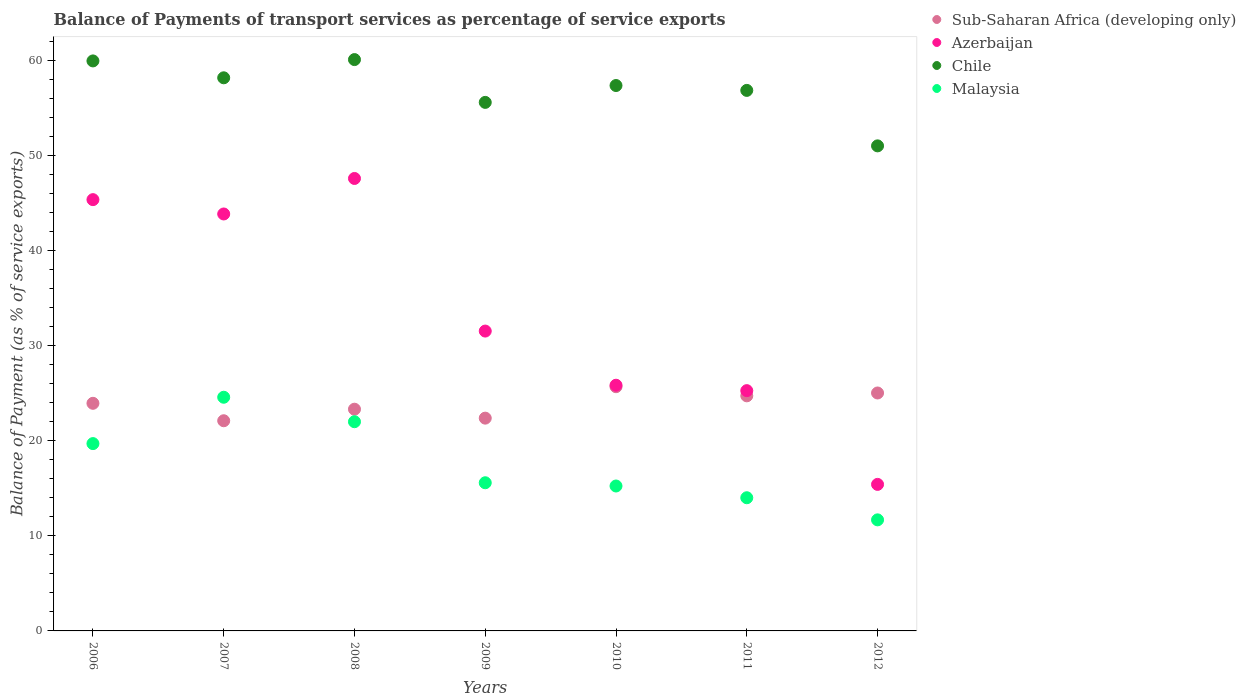How many different coloured dotlines are there?
Your response must be concise. 4. What is the balance of payments of transport services in Chile in 2010?
Give a very brief answer. 57.36. Across all years, what is the maximum balance of payments of transport services in Azerbaijan?
Your response must be concise. 47.58. Across all years, what is the minimum balance of payments of transport services in Chile?
Make the answer very short. 51.01. In which year was the balance of payments of transport services in Chile maximum?
Your answer should be compact. 2008. What is the total balance of payments of transport services in Malaysia in the graph?
Ensure brevity in your answer.  122.78. What is the difference between the balance of payments of transport services in Chile in 2010 and that in 2011?
Offer a terse response. 0.51. What is the difference between the balance of payments of transport services in Malaysia in 2006 and the balance of payments of transport services in Sub-Saharan Africa (developing only) in 2007?
Offer a very short reply. -2.4. What is the average balance of payments of transport services in Chile per year?
Provide a succinct answer. 57. In the year 2007, what is the difference between the balance of payments of transport services in Chile and balance of payments of transport services in Sub-Saharan Africa (developing only)?
Offer a terse response. 36.06. What is the ratio of the balance of payments of transport services in Malaysia in 2007 to that in 2010?
Offer a terse response. 1.61. Is the balance of payments of transport services in Sub-Saharan Africa (developing only) in 2006 less than that in 2008?
Give a very brief answer. No. What is the difference between the highest and the second highest balance of payments of transport services in Chile?
Give a very brief answer. 0.14. What is the difference between the highest and the lowest balance of payments of transport services in Sub-Saharan Africa (developing only)?
Your response must be concise. 3.58. In how many years, is the balance of payments of transport services in Sub-Saharan Africa (developing only) greater than the average balance of payments of transport services in Sub-Saharan Africa (developing only) taken over all years?
Make the answer very short. 4. Is it the case that in every year, the sum of the balance of payments of transport services in Chile and balance of payments of transport services in Malaysia  is greater than the sum of balance of payments of transport services in Sub-Saharan Africa (developing only) and balance of payments of transport services in Azerbaijan?
Keep it short and to the point. Yes. Does the balance of payments of transport services in Sub-Saharan Africa (developing only) monotonically increase over the years?
Provide a short and direct response. No. Is the balance of payments of transport services in Azerbaijan strictly less than the balance of payments of transport services in Chile over the years?
Provide a short and direct response. Yes. How many dotlines are there?
Provide a short and direct response. 4. Are the values on the major ticks of Y-axis written in scientific E-notation?
Your answer should be very brief. No. Does the graph contain any zero values?
Provide a succinct answer. No. Does the graph contain grids?
Provide a succinct answer. No. What is the title of the graph?
Your answer should be compact. Balance of Payments of transport services as percentage of service exports. Does "Switzerland" appear as one of the legend labels in the graph?
Keep it short and to the point. No. What is the label or title of the X-axis?
Your response must be concise. Years. What is the label or title of the Y-axis?
Provide a short and direct response. Balance of Payment (as % of service exports). What is the Balance of Payment (as % of service exports) of Sub-Saharan Africa (developing only) in 2006?
Your answer should be very brief. 23.94. What is the Balance of Payment (as % of service exports) of Azerbaijan in 2006?
Offer a terse response. 45.35. What is the Balance of Payment (as % of service exports) of Chile in 2006?
Make the answer very short. 59.94. What is the Balance of Payment (as % of service exports) in Malaysia in 2006?
Ensure brevity in your answer.  19.7. What is the Balance of Payment (as % of service exports) of Sub-Saharan Africa (developing only) in 2007?
Your response must be concise. 22.1. What is the Balance of Payment (as % of service exports) in Azerbaijan in 2007?
Offer a terse response. 43.85. What is the Balance of Payment (as % of service exports) in Chile in 2007?
Provide a succinct answer. 58.17. What is the Balance of Payment (as % of service exports) in Malaysia in 2007?
Make the answer very short. 24.57. What is the Balance of Payment (as % of service exports) of Sub-Saharan Africa (developing only) in 2008?
Offer a terse response. 23.32. What is the Balance of Payment (as % of service exports) in Azerbaijan in 2008?
Make the answer very short. 47.58. What is the Balance of Payment (as % of service exports) in Chile in 2008?
Offer a terse response. 60.08. What is the Balance of Payment (as % of service exports) in Malaysia in 2008?
Provide a succinct answer. 22. What is the Balance of Payment (as % of service exports) of Sub-Saharan Africa (developing only) in 2009?
Make the answer very short. 22.38. What is the Balance of Payment (as % of service exports) of Azerbaijan in 2009?
Your answer should be very brief. 31.53. What is the Balance of Payment (as % of service exports) in Chile in 2009?
Give a very brief answer. 55.58. What is the Balance of Payment (as % of service exports) of Malaysia in 2009?
Your answer should be very brief. 15.58. What is the Balance of Payment (as % of service exports) of Sub-Saharan Africa (developing only) in 2010?
Offer a terse response. 25.68. What is the Balance of Payment (as % of service exports) in Azerbaijan in 2010?
Offer a terse response. 25.84. What is the Balance of Payment (as % of service exports) of Chile in 2010?
Provide a short and direct response. 57.36. What is the Balance of Payment (as % of service exports) in Malaysia in 2010?
Ensure brevity in your answer.  15.24. What is the Balance of Payment (as % of service exports) in Sub-Saharan Africa (developing only) in 2011?
Offer a terse response. 24.72. What is the Balance of Payment (as % of service exports) in Azerbaijan in 2011?
Your answer should be very brief. 25.27. What is the Balance of Payment (as % of service exports) in Chile in 2011?
Make the answer very short. 56.84. What is the Balance of Payment (as % of service exports) in Malaysia in 2011?
Keep it short and to the point. 14.01. What is the Balance of Payment (as % of service exports) of Sub-Saharan Africa (developing only) in 2012?
Your answer should be very brief. 25.02. What is the Balance of Payment (as % of service exports) in Azerbaijan in 2012?
Your response must be concise. 15.41. What is the Balance of Payment (as % of service exports) in Chile in 2012?
Give a very brief answer. 51.01. What is the Balance of Payment (as % of service exports) in Malaysia in 2012?
Give a very brief answer. 11.68. Across all years, what is the maximum Balance of Payment (as % of service exports) of Sub-Saharan Africa (developing only)?
Keep it short and to the point. 25.68. Across all years, what is the maximum Balance of Payment (as % of service exports) in Azerbaijan?
Ensure brevity in your answer.  47.58. Across all years, what is the maximum Balance of Payment (as % of service exports) of Chile?
Your answer should be compact. 60.08. Across all years, what is the maximum Balance of Payment (as % of service exports) in Malaysia?
Offer a very short reply. 24.57. Across all years, what is the minimum Balance of Payment (as % of service exports) in Sub-Saharan Africa (developing only)?
Your answer should be compact. 22.1. Across all years, what is the minimum Balance of Payment (as % of service exports) in Azerbaijan?
Give a very brief answer. 15.41. Across all years, what is the minimum Balance of Payment (as % of service exports) of Chile?
Give a very brief answer. 51.01. Across all years, what is the minimum Balance of Payment (as % of service exports) of Malaysia?
Your answer should be very brief. 11.68. What is the total Balance of Payment (as % of service exports) in Sub-Saharan Africa (developing only) in the graph?
Give a very brief answer. 167.16. What is the total Balance of Payment (as % of service exports) of Azerbaijan in the graph?
Offer a terse response. 234.83. What is the total Balance of Payment (as % of service exports) in Chile in the graph?
Ensure brevity in your answer.  398.98. What is the total Balance of Payment (as % of service exports) in Malaysia in the graph?
Provide a short and direct response. 122.78. What is the difference between the Balance of Payment (as % of service exports) of Sub-Saharan Africa (developing only) in 2006 and that in 2007?
Provide a succinct answer. 1.83. What is the difference between the Balance of Payment (as % of service exports) of Azerbaijan in 2006 and that in 2007?
Make the answer very short. 1.51. What is the difference between the Balance of Payment (as % of service exports) in Chile in 2006 and that in 2007?
Provide a short and direct response. 1.78. What is the difference between the Balance of Payment (as % of service exports) of Malaysia in 2006 and that in 2007?
Provide a succinct answer. -4.87. What is the difference between the Balance of Payment (as % of service exports) of Sub-Saharan Africa (developing only) in 2006 and that in 2008?
Give a very brief answer. 0.62. What is the difference between the Balance of Payment (as % of service exports) in Azerbaijan in 2006 and that in 2008?
Provide a succinct answer. -2.23. What is the difference between the Balance of Payment (as % of service exports) of Chile in 2006 and that in 2008?
Offer a very short reply. -0.14. What is the difference between the Balance of Payment (as % of service exports) of Malaysia in 2006 and that in 2008?
Your answer should be compact. -2.3. What is the difference between the Balance of Payment (as % of service exports) of Sub-Saharan Africa (developing only) in 2006 and that in 2009?
Your answer should be very brief. 1.56. What is the difference between the Balance of Payment (as % of service exports) in Azerbaijan in 2006 and that in 2009?
Your response must be concise. 13.82. What is the difference between the Balance of Payment (as % of service exports) of Chile in 2006 and that in 2009?
Give a very brief answer. 4.36. What is the difference between the Balance of Payment (as % of service exports) of Malaysia in 2006 and that in 2009?
Offer a very short reply. 4.12. What is the difference between the Balance of Payment (as % of service exports) of Sub-Saharan Africa (developing only) in 2006 and that in 2010?
Your answer should be very brief. -1.75. What is the difference between the Balance of Payment (as % of service exports) of Azerbaijan in 2006 and that in 2010?
Give a very brief answer. 19.52. What is the difference between the Balance of Payment (as % of service exports) in Chile in 2006 and that in 2010?
Keep it short and to the point. 2.59. What is the difference between the Balance of Payment (as % of service exports) in Malaysia in 2006 and that in 2010?
Make the answer very short. 4.46. What is the difference between the Balance of Payment (as % of service exports) of Sub-Saharan Africa (developing only) in 2006 and that in 2011?
Your response must be concise. -0.79. What is the difference between the Balance of Payment (as % of service exports) in Azerbaijan in 2006 and that in 2011?
Provide a succinct answer. 20.09. What is the difference between the Balance of Payment (as % of service exports) of Chile in 2006 and that in 2011?
Offer a terse response. 3.1. What is the difference between the Balance of Payment (as % of service exports) in Malaysia in 2006 and that in 2011?
Offer a terse response. 5.69. What is the difference between the Balance of Payment (as % of service exports) in Sub-Saharan Africa (developing only) in 2006 and that in 2012?
Keep it short and to the point. -1.09. What is the difference between the Balance of Payment (as % of service exports) in Azerbaijan in 2006 and that in 2012?
Offer a very short reply. 29.94. What is the difference between the Balance of Payment (as % of service exports) of Chile in 2006 and that in 2012?
Ensure brevity in your answer.  8.93. What is the difference between the Balance of Payment (as % of service exports) of Malaysia in 2006 and that in 2012?
Your answer should be very brief. 8.02. What is the difference between the Balance of Payment (as % of service exports) in Sub-Saharan Africa (developing only) in 2007 and that in 2008?
Ensure brevity in your answer.  -1.21. What is the difference between the Balance of Payment (as % of service exports) of Azerbaijan in 2007 and that in 2008?
Your response must be concise. -3.73. What is the difference between the Balance of Payment (as % of service exports) of Chile in 2007 and that in 2008?
Provide a short and direct response. -1.92. What is the difference between the Balance of Payment (as % of service exports) in Malaysia in 2007 and that in 2008?
Keep it short and to the point. 2.57. What is the difference between the Balance of Payment (as % of service exports) in Sub-Saharan Africa (developing only) in 2007 and that in 2009?
Keep it short and to the point. -0.27. What is the difference between the Balance of Payment (as % of service exports) in Azerbaijan in 2007 and that in 2009?
Make the answer very short. 12.31. What is the difference between the Balance of Payment (as % of service exports) of Chile in 2007 and that in 2009?
Make the answer very short. 2.59. What is the difference between the Balance of Payment (as % of service exports) of Malaysia in 2007 and that in 2009?
Keep it short and to the point. 8.99. What is the difference between the Balance of Payment (as % of service exports) of Sub-Saharan Africa (developing only) in 2007 and that in 2010?
Make the answer very short. -3.58. What is the difference between the Balance of Payment (as % of service exports) of Azerbaijan in 2007 and that in 2010?
Provide a succinct answer. 18.01. What is the difference between the Balance of Payment (as % of service exports) in Chile in 2007 and that in 2010?
Your answer should be compact. 0.81. What is the difference between the Balance of Payment (as % of service exports) of Malaysia in 2007 and that in 2010?
Provide a short and direct response. 9.33. What is the difference between the Balance of Payment (as % of service exports) of Sub-Saharan Africa (developing only) in 2007 and that in 2011?
Provide a short and direct response. -2.62. What is the difference between the Balance of Payment (as % of service exports) of Azerbaijan in 2007 and that in 2011?
Offer a terse response. 18.58. What is the difference between the Balance of Payment (as % of service exports) in Chile in 2007 and that in 2011?
Provide a short and direct response. 1.32. What is the difference between the Balance of Payment (as % of service exports) of Malaysia in 2007 and that in 2011?
Your answer should be compact. 10.57. What is the difference between the Balance of Payment (as % of service exports) in Sub-Saharan Africa (developing only) in 2007 and that in 2012?
Your answer should be compact. -2.92. What is the difference between the Balance of Payment (as % of service exports) in Azerbaijan in 2007 and that in 2012?
Offer a terse response. 28.44. What is the difference between the Balance of Payment (as % of service exports) in Chile in 2007 and that in 2012?
Give a very brief answer. 7.16. What is the difference between the Balance of Payment (as % of service exports) of Malaysia in 2007 and that in 2012?
Give a very brief answer. 12.89. What is the difference between the Balance of Payment (as % of service exports) of Sub-Saharan Africa (developing only) in 2008 and that in 2009?
Offer a very short reply. 0.94. What is the difference between the Balance of Payment (as % of service exports) of Azerbaijan in 2008 and that in 2009?
Make the answer very short. 16.05. What is the difference between the Balance of Payment (as % of service exports) in Chile in 2008 and that in 2009?
Offer a terse response. 4.5. What is the difference between the Balance of Payment (as % of service exports) of Malaysia in 2008 and that in 2009?
Your response must be concise. 6.42. What is the difference between the Balance of Payment (as % of service exports) of Sub-Saharan Africa (developing only) in 2008 and that in 2010?
Your answer should be compact. -2.37. What is the difference between the Balance of Payment (as % of service exports) of Azerbaijan in 2008 and that in 2010?
Your answer should be very brief. 21.74. What is the difference between the Balance of Payment (as % of service exports) of Chile in 2008 and that in 2010?
Offer a very short reply. 2.73. What is the difference between the Balance of Payment (as % of service exports) of Malaysia in 2008 and that in 2010?
Ensure brevity in your answer.  6.76. What is the difference between the Balance of Payment (as % of service exports) in Sub-Saharan Africa (developing only) in 2008 and that in 2011?
Keep it short and to the point. -1.41. What is the difference between the Balance of Payment (as % of service exports) of Azerbaijan in 2008 and that in 2011?
Give a very brief answer. 22.31. What is the difference between the Balance of Payment (as % of service exports) in Chile in 2008 and that in 2011?
Your response must be concise. 3.24. What is the difference between the Balance of Payment (as % of service exports) in Malaysia in 2008 and that in 2011?
Offer a terse response. 8. What is the difference between the Balance of Payment (as % of service exports) in Sub-Saharan Africa (developing only) in 2008 and that in 2012?
Make the answer very short. -1.71. What is the difference between the Balance of Payment (as % of service exports) in Azerbaijan in 2008 and that in 2012?
Your response must be concise. 32.17. What is the difference between the Balance of Payment (as % of service exports) in Chile in 2008 and that in 2012?
Provide a succinct answer. 9.07. What is the difference between the Balance of Payment (as % of service exports) in Malaysia in 2008 and that in 2012?
Provide a succinct answer. 10.32. What is the difference between the Balance of Payment (as % of service exports) in Sub-Saharan Africa (developing only) in 2009 and that in 2010?
Provide a short and direct response. -3.3. What is the difference between the Balance of Payment (as % of service exports) in Azerbaijan in 2009 and that in 2010?
Your answer should be very brief. 5.69. What is the difference between the Balance of Payment (as % of service exports) in Chile in 2009 and that in 2010?
Keep it short and to the point. -1.77. What is the difference between the Balance of Payment (as % of service exports) of Malaysia in 2009 and that in 2010?
Provide a succinct answer. 0.34. What is the difference between the Balance of Payment (as % of service exports) of Sub-Saharan Africa (developing only) in 2009 and that in 2011?
Offer a very short reply. -2.35. What is the difference between the Balance of Payment (as % of service exports) of Azerbaijan in 2009 and that in 2011?
Give a very brief answer. 6.26. What is the difference between the Balance of Payment (as % of service exports) of Chile in 2009 and that in 2011?
Your answer should be compact. -1.26. What is the difference between the Balance of Payment (as % of service exports) of Malaysia in 2009 and that in 2011?
Your answer should be very brief. 1.58. What is the difference between the Balance of Payment (as % of service exports) in Sub-Saharan Africa (developing only) in 2009 and that in 2012?
Keep it short and to the point. -2.65. What is the difference between the Balance of Payment (as % of service exports) in Azerbaijan in 2009 and that in 2012?
Provide a succinct answer. 16.12. What is the difference between the Balance of Payment (as % of service exports) in Chile in 2009 and that in 2012?
Your answer should be very brief. 4.57. What is the difference between the Balance of Payment (as % of service exports) in Malaysia in 2009 and that in 2012?
Provide a succinct answer. 3.9. What is the difference between the Balance of Payment (as % of service exports) in Sub-Saharan Africa (developing only) in 2010 and that in 2011?
Make the answer very short. 0.96. What is the difference between the Balance of Payment (as % of service exports) of Azerbaijan in 2010 and that in 2011?
Offer a very short reply. 0.57. What is the difference between the Balance of Payment (as % of service exports) in Chile in 2010 and that in 2011?
Provide a succinct answer. 0.51. What is the difference between the Balance of Payment (as % of service exports) in Malaysia in 2010 and that in 2011?
Ensure brevity in your answer.  1.23. What is the difference between the Balance of Payment (as % of service exports) in Sub-Saharan Africa (developing only) in 2010 and that in 2012?
Your response must be concise. 0.66. What is the difference between the Balance of Payment (as % of service exports) of Azerbaijan in 2010 and that in 2012?
Make the answer very short. 10.43. What is the difference between the Balance of Payment (as % of service exports) of Chile in 2010 and that in 2012?
Keep it short and to the point. 6.35. What is the difference between the Balance of Payment (as % of service exports) in Malaysia in 2010 and that in 2012?
Your answer should be compact. 3.56. What is the difference between the Balance of Payment (as % of service exports) of Sub-Saharan Africa (developing only) in 2011 and that in 2012?
Your response must be concise. -0.3. What is the difference between the Balance of Payment (as % of service exports) in Azerbaijan in 2011 and that in 2012?
Ensure brevity in your answer.  9.86. What is the difference between the Balance of Payment (as % of service exports) of Chile in 2011 and that in 2012?
Make the answer very short. 5.83. What is the difference between the Balance of Payment (as % of service exports) in Malaysia in 2011 and that in 2012?
Provide a short and direct response. 2.33. What is the difference between the Balance of Payment (as % of service exports) in Sub-Saharan Africa (developing only) in 2006 and the Balance of Payment (as % of service exports) in Azerbaijan in 2007?
Your response must be concise. -19.91. What is the difference between the Balance of Payment (as % of service exports) of Sub-Saharan Africa (developing only) in 2006 and the Balance of Payment (as % of service exports) of Chile in 2007?
Your answer should be very brief. -34.23. What is the difference between the Balance of Payment (as % of service exports) in Sub-Saharan Africa (developing only) in 2006 and the Balance of Payment (as % of service exports) in Malaysia in 2007?
Offer a terse response. -0.64. What is the difference between the Balance of Payment (as % of service exports) of Azerbaijan in 2006 and the Balance of Payment (as % of service exports) of Chile in 2007?
Offer a very short reply. -12.81. What is the difference between the Balance of Payment (as % of service exports) in Azerbaijan in 2006 and the Balance of Payment (as % of service exports) in Malaysia in 2007?
Your response must be concise. 20.78. What is the difference between the Balance of Payment (as % of service exports) of Chile in 2006 and the Balance of Payment (as % of service exports) of Malaysia in 2007?
Give a very brief answer. 35.37. What is the difference between the Balance of Payment (as % of service exports) in Sub-Saharan Africa (developing only) in 2006 and the Balance of Payment (as % of service exports) in Azerbaijan in 2008?
Offer a terse response. -23.65. What is the difference between the Balance of Payment (as % of service exports) in Sub-Saharan Africa (developing only) in 2006 and the Balance of Payment (as % of service exports) in Chile in 2008?
Keep it short and to the point. -36.15. What is the difference between the Balance of Payment (as % of service exports) in Sub-Saharan Africa (developing only) in 2006 and the Balance of Payment (as % of service exports) in Malaysia in 2008?
Your answer should be compact. 1.94. What is the difference between the Balance of Payment (as % of service exports) of Azerbaijan in 2006 and the Balance of Payment (as % of service exports) of Chile in 2008?
Your answer should be very brief. -14.73. What is the difference between the Balance of Payment (as % of service exports) of Azerbaijan in 2006 and the Balance of Payment (as % of service exports) of Malaysia in 2008?
Give a very brief answer. 23.35. What is the difference between the Balance of Payment (as % of service exports) in Chile in 2006 and the Balance of Payment (as % of service exports) in Malaysia in 2008?
Your answer should be compact. 37.94. What is the difference between the Balance of Payment (as % of service exports) in Sub-Saharan Africa (developing only) in 2006 and the Balance of Payment (as % of service exports) in Azerbaijan in 2009?
Give a very brief answer. -7.6. What is the difference between the Balance of Payment (as % of service exports) of Sub-Saharan Africa (developing only) in 2006 and the Balance of Payment (as % of service exports) of Chile in 2009?
Your answer should be compact. -31.65. What is the difference between the Balance of Payment (as % of service exports) in Sub-Saharan Africa (developing only) in 2006 and the Balance of Payment (as % of service exports) in Malaysia in 2009?
Offer a very short reply. 8.36. What is the difference between the Balance of Payment (as % of service exports) of Azerbaijan in 2006 and the Balance of Payment (as % of service exports) of Chile in 2009?
Provide a succinct answer. -10.23. What is the difference between the Balance of Payment (as % of service exports) of Azerbaijan in 2006 and the Balance of Payment (as % of service exports) of Malaysia in 2009?
Make the answer very short. 29.77. What is the difference between the Balance of Payment (as % of service exports) of Chile in 2006 and the Balance of Payment (as % of service exports) of Malaysia in 2009?
Your response must be concise. 44.36. What is the difference between the Balance of Payment (as % of service exports) of Sub-Saharan Africa (developing only) in 2006 and the Balance of Payment (as % of service exports) of Azerbaijan in 2010?
Offer a very short reply. -1.9. What is the difference between the Balance of Payment (as % of service exports) of Sub-Saharan Africa (developing only) in 2006 and the Balance of Payment (as % of service exports) of Chile in 2010?
Your response must be concise. -33.42. What is the difference between the Balance of Payment (as % of service exports) of Sub-Saharan Africa (developing only) in 2006 and the Balance of Payment (as % of service exports) of Malaysia in 2010?
Ensure brevity in your answer.  8.7. What is the difference between the Balance of Payment (as % of service exports) in Azerbaijan in 2006 and the Balance of Payment (as % of service exports) in Chile in 2010?
Your answer should be compact. -12. What is the difference between the Balance of Payment (as % of service exports) of Azerbaijan in 2006 and the Balance of Payment (as % of service exports) of Malaysia in 2010?
Provide a short and direct response. 30.11. What is the difference between the Balance of Payment (as % of service exports) in Chile in 2006 and the Balance of Payment (as % of service exports) in Malaysia in 2010?
Offer a very short reply. 44.7. What is the difference between the Balance of Payment (as % of service exports) of Sub-Saharan Africa (developing only) in 2006 and the Balance of Payment (as % of service exports) of Azerbaijan in 2011?
Keep it short and to the point. -1.33. What is the difference between the Balance of Payment (as % of service exports) in Sub-Saharan Africa (developing only) in 2006 and the Balance of Payment (as % of service exports) in Chile in 2011?
Keep it short and to the point. -32.91. What is the difference between the Balance of Payment (as % of service exports) in Sub-Saharan Africa (developing only) in 2006 and the Balance of Payment (as % of service exports) in Malaysia in 2011?
Your response must be concise. 9.93. What is the difference between the Balance of Payment (as % of service exports) in Azerbaijan in 2006 and the Balance of Payment (as % of service exports) in Chile in 2011?
Offer a terse response. -11.49. What is the difference between the Balance of Payment (as % of service exports) of Azerbaijan in 2006 and the Balance of Payment (as % of service exports) of Malaysia in 2011?
Your answer should be compact. 31.35. What is the difference between the Balance of Payment (as % of service exports) of Chile in 2006 and the Balance of Payment (as % of service exports) of Malaysia in 2011?
Keep it short and to the point. 45.94. What is the difference between the Balance of Payment (as % of service exports) in Sub-Saharan Africa (developing only) in 2006 and the Balance of Payment (as % of service exports) in Azerbaijan in 2012?
Your answer should be compact. 8.53. What is the difference between the Balance of Payment (as % of service exports) of Sub-Saharan Africa (developing only) in 2006 and the Balance of Payment (as % of service exports) of Chile in 2012?
Provide a short and direct response. -27.07. What is the difference between the Balance of Payment (as % of service exports) of Sub-Saharan Africa (developing only) in 2006 and the Balance of Payment (as % of service exports) of Malaysia in 2012?
Offer a very short reply. 12.26. What is the difference between the Balance of Payment (as % of service exports) of Azerbaijan in 2006 and the Balance of Payment (as % of service exports) of Chile in 2012?
Ensure brevity in your answer.  -5.65. What is the difference between the Balance of Payment (as % of service exports) of Azerbaijan in 2006 and the Balance of Payment (as % of service exports) of Malaysia in 2012?
Your answer should be compact. 33.68. What is the difference between the Balance of Payment (as % of service exports) of Chile in 2006 and the Balance of Payment (as % of service exports) of Malaysia in 2012?
Provide a succinct answer. 48.26. What is the difference between the Balance of Payment (as % of service exports) in Sub-Saharan Africa (developing only) in 2007 and the Balance of Payment (as % of service exports) in Azerbaijan in 2008?
Provide a short and direct response. -25.48. What is the difference between the Balance of Payment (as % of service exports) of Sub-Saharan Africa (developing only) in 2007 and the Balance of Payment (as % of service exports) of Chile in 2008?
Provide a short and direct response. -37.98. What is the difference between the Balance of Payment (as % of service exports) of Sub-Saharan Africa (developing only) in 2007 and the Balance of Payment (as % of service exports) of Malaysia in 2008?
Give a very brief answer. 0.1. What is the difference between the Balance of Payment (as % of service exports) in Azerbaijan in 2007 and the Balance of Payment (as % of service exports) in Chile in 2008?
Offer a very short reply. -16.24. What is the difference between the Balance of Payment (as % of service exports) in Azerbaijan in 2007 and the Balance of Payment (as % of service exports) in Malaysia in 2008?
Offer a terse response. 21.85. What is the difference between the Balance of Payment (as % of service exports) of Chile in 2007 and the Balance of Payment (as % of service exports) of Malaysia in 2008?
Keep it short and to the point. 36.17. What is the difference between the Balance of Payment (as % of service exports) of Sub-Saharan Africa (developing only) in 2007 and the Balance of Payment (as % of service exports) of Azerbaijan in 2009?
Offer a very short reply. -9.43. What is the difference between the Balance of Payment (as % of service exports) in Sub-Saharan Africa (developing only) in 2007 and the Balance of Payment (as % of service exports) in Chile in 2009?
Provide a succinct answer. -33.48. What is the difference between the Balance of Payment (as % of service exports) in Sub-Saharan Africa (developing only) in 2007 and the Balance of Payment (as % of service exports) in Malaysia in 2009?
Your response must be concise. 6.52. What is the difference between the Balance of Payment (as % of service exports) in Azerbaijan in 2007 and the Balance of Payment (as % of service exports) in Chile in 2009?
Ensure brevity in your answer.  -11.73. What is the difference between the Balance of Payment (as % of service exports) in Azerbaijan in 2007 and the Balance of Payment (as % of service exports) in Malaysia in 2009?
Make the answer very short. 28.27. What is the difference between the Balance of Payment (as % of service exports) of Chile in 2007 and the Balance of Payment (as % of service exports) of Malaysia in 2009?
Provide a short and direct response. 42.59. What is the difference between the Balance of Payment (as % of service exports) of Sub-Saharan Africa (developing only) in 2007 and the Balance of Payment (as % of service exports) of Azerbaijan in 2010?
Offer a very short reply. -3.74. What is the difference between the Balance of Payment (as % of service exports) of Sub-Saharan Africa (developing only) in 2007 and the Balance of Payment (as % of service exports) of Chile in 2010?
Ensure brevity in your answer.  -35.25. What is the difference between the Balance of Payment (as % of service exports) of Sub-Saharan Africa (developing only) in 2007 and the Balance of Payment (as % of service exports) of Malaysia in 2010?
Make the answer very short. 6.86. What is the difference between the Balance of Payment (as % of service exports) of Azerbaijan in 2007 and the Balance of Payment (as % of service exports) of Chile in 2010?
Give a very brief answer. -13.51. What is the difference between the Balance of Payment (as % of service exports) in Azerbaijan in 2007 and the Balance of Payment (as % of service exports) in Malaysia in 2010?
Ensure brevity in your answer.  28.61. What is the difference between the Balance of Payment (as % of service exports) of Chile in 2007 and the Balance of Payment (as % of service exports) of Malaysia in 2010?
Make the answer very short. 42.93. What is the difference between the Balance of Payment (as % of service exports) of Sub-Saharan Africa (developing only) in 2007 and the Balance of Payment (as % of service exports) of Azerbaijan in 2011?
Make the answer very short. -3.17. What is the difference between the Balance of Payment (as % of service exports) in Sub-Saharan Africa (developing only) in 2007 and the Balance of Payment (as % of service exports) in Chile in 2011?
Your response must be concise. -34.74. What is the difference between the Balance of Payment (as % of service exports) in Sub-Saharan Africa (developing only) in 2007 and the Balance of Payment (as % of service exports) in Malaysia in 2011?
Your response must be concise. 8.1. What is the difference between the Balance of Payment (as % of service exports) of Azerbaijan in 2007 and the Balance of Payment (as % of service exports) of Chile in 2011?
Your answer should be very brief. -13. What is the difference between the Balance of Payment (as % of service exports) of Azerbaijan in 2007 and the Balance of Payment (as % of service exports) of Malaysia in 2011?
Ensure brevity in your answer.  29.84. What is the difference between the Balance of Payment (as % of service exports) in Chile in 2007 and the Balance of Payment (as % of service exports) in Malaysia in 2011?
Give a very brief answer. 44.16. What is the difference between the Balance of Payment (as % of service exports) in Sub-Saharan Africa (developing only) in 2007 and the Balance of Payment (as % of service exports) in Azerbaijan in 2012?
Your response must be concise. 6.69. What is the difference between the Balance of Payment (as % of service exports) in Sub-Saharan Africa (developing only) in 2007 and the Balance of Payment (as % of service exports) in Chile in 2012?
Provide a succinct answer. -28.91. What is the difference between the Balance of Payment (as % of service exports) in Sub-Saharan Africa (developing only) in 2007 and the Balance of Payment (as % of service exports) in Malaysia in 2012?
Provide a succinct answer. 10.42. What is the difference between the Balance of Payment (as % of service exports) of Azerbaijan in 2007 and the Balance of Payment (as % of service exports) of Chile in 2012?
Offer a very short reply. -7.16. What is the difference between the Balance of Payment (as % of service exports) of Azerbaijan in 2007 and the Balance of Payment (as % of service exports) of Malaysia in 2012?
Keep it short and to the point. 32.17. What is the difference between the Balance of Payment (as % of service exports) of Chile in 2007 and the Balance of Payment (as % of service exports) of Malaysia in 2012?
Your answer should be very brief. 46.49. What is the difference between the Balance of Payment (as % of service exports) in Sub-Saharan Africa (developing only) in 2008 and the Balance of Payment (as % of service exports) in Azerbaijan in 2009?
Your answer should be compact. -8.22. What is the difference between the Balance of Payment (as % of service exports) in Sub-Saharan Africa (developing only) in 2008 and the Balance of Payment (as % of service exports) in Chile in 2009?
Make the answer very short. -32.27. What is the difference between the Balance of Payment (as % of service exports) of Sub-Saharan Africa (developing only) in 2008 and the Balance of Payment (as % of service exports) of Malaysia in 2009?
Provide a short and direct response. 7.74. What is the difference between the Balance of Payment (as % of service exports) of Azerbaijan in 2008 and the Balance of Payment (as % of service exports) of Chile in 2009?
Provide a succinct answer. -8. What is the difference between the Balance of Payment (as % of service exports) of Azerbaijan in 2008 and the Balance of Payment (as % of service exports) of Malaysia in 2009?
Make the answer very short. 32. What is the difference between the Balance of Payment (as % of service exports) of Chile in 2008 and the Balance of Payment (as % of service exports) of Malaysia in 2009?
Make the answer very short. 44.5. What is the difference between the Balance of Payment (as % of service exports) in Sub-Saharan Africa (developing only) in 2008 and the Balance of Payment (as % of service exports) in Azerbaijan in 2010?
Give a very brief answer. -2.52. What is the difference between the Balance of Payment (as % of service exports) in Sub-Saharan Africa (developing only) in 2008 and the Balance of Payment (as % of service exports) in Chile in 2010?
Provide a short and direct response. -34.04. What is the difference between the Balance of Payment (as % of service exports) of Sub-Saharan Africa (developing only) in 2008 and the Balance of Payment (as % of service exports) of Malaysia in 2010?
Offer a very short reply. 8.08. What is the difference between the Balance of Payment (as % of service exports) of Azerbaijan in 2008 and the Balance of Payment (as % of service exports) of Chile in 2010?
Offer a terse response. -9.77. What is the difference between the Balance of Payment (as % of service exports) in Azerbaijan in 2008 and the Balance of Payment (as % of service exports) in Malaysia in 2010?
Your response must be concise. 32.34. What is the difference between the Balance of Payment (as % of service exports) of Chile in 2008 and the Balance of Payment (as % of service exports) of Malaysia in 2010?
Make the answer very short. 44.84. What is the difference between the Balance of Payment (as % of service exports) of Sub-Saharan Africa (developing only) in 2008 and the Balance of Payment (as % of service exports) of Azerbaijan in 2011?
Provide a short and direct response. -1.95. What is the difference between the Balance of Payment (as % of service exports) in Sub-Saharan Africa (developing only) in 2008 and the Balance of Payment (as % of service exports) in Chile in 2011?
Offer a terse response. -33.53. What is the difference between the Balance of Payment (as % of service exports) of Sub-Saharan Africa (developing only) in 2008 and the Balance of Payment (as % of service exports) of Malaysia in 2011?
Your response must be concise. 9.31. What is the difference between the Balance of Payment (as % of service exports) of Azerbaijan in 2008 and the Balance of Payment (as % of service exports) of Chile in 2011?
Make the answer very short. -9.26. What is the difference between the Balance of Payment (as % of service exports) of Azerbaijan in 2008 and the Balance of Payment (as % of service exports) of Malaysia in 2011?
Keep it short and to the point. 33.58. What is the difference between the Balance of Payment (as % of service exports) of Chile in 2008 and the Balance of Payment (as % of service exports) of Malaysia in 2011?
Your response must be concise. 46.08. What is the difference between the Balance of Payment (as % of service exports) of Sub-Saharan Africa (developing only) in 2008 and the Balance of Payment (as % of service exports) of Azerbaijan in 2012?
Provide a succinct answer. 7.91. What is the difference between the Balance of Payment (as % of service exports) in Sub-Saharan Africa (developing only) in 2008 and the Balance of Payment (as % of service exports) in Chile in 2012?
Keep it short and to the point. -27.69. What is the difference between the Balance of Payment (as % of service exports) in Sub-Saharan Africa (developing only) in 2008 and the Balance of Payment (as % of service exports) in Malaysia in 2012?
Provide a short and direct response. 11.64. What is the difference between the Balance of Payment (as % of service exports) in Azerbaijan in 2008 and the Balance of Payment (as % of service exports) in Chile in 2012?
Provide a short and direct response. -3.43. What is the difference between the Balance of Payment (as % of service exports) of Azerbaijan in 2008 and the Balance of Payment (as % of service exports) of Malaysia in 2012?
Offer a terse response. 35.9. What is the difference between the Balance of Payment (as % of service exports) in Chile in 2008 and the Balance of Payment (as % of service exports) in Malaysia in 2012?
Your answer should be very brief. 48.4. What is the difference between the Balance of Payment (as % of service exports) of Sub-Saharan Africa (developing only) in 2009 and the Balance of Payment (as % of service exports) of Azerbaijan in 2010?
Offer a terse response. -3.46. What is the difference between the Balance of Payment (as % of service exports) in Sub-Saharan Africa (developing only) in 2009 and the Balance of Payment (as % of service exports) in Chile in 2010?
Your answer should be very brief. -34.98. What is the difference between the Balance of Payment (as % of service exports) in Sub-Saharan Africa (developing only) in 2009 and the Balance of Payment (as % of service exports) in Malaysia in 2010?
Give a very brief answer. 7.14. What is the difference between the Balance of Payment (as % of service exports) of Azerbaijan in 2009 and the Balance of Payment (as % of service exports) of Chile in 2010?
Provide a succinct answer. -25.82. What is the difference between the Balance of Payment (as % of service exports) of Azerbaijan in 2009 and the Balance of Payment (as % of service exports) of Malaysia in 2010?
Offer a terse response. 16.29. What is the difference between the Balance of Payment (as % of service exports) in Chile in 2009 and the Balance of Payment (as % of service exports) in Malaysia in 2010?
Ensure brevity in your answer.  40.34. What is the difference between the Balance of Payment (as % of service exports) of Sub-Saharan Africa (developing only) in 2009 and the Balance of Payment (as % of service exports) of Azerbaijan in 2011?
Give a very brief answer. -2.89. What is the difference between the Balance of Payment (as % of service exports) of Sub-Saharan Africa (developing only) in 2009 and the Balance of Payment (as % of service exports) of Chile in 2011?
Ensure brevity in your answer.  -34.47. What is the difference between the Balance of Payment (as % of service exports) in Sub-Saharan Africa (developing only) in 2009 and the Balance of Payment (as % of service exports) in Malaysia in 2011?
Make the answer very short. 8.37. What is the difference between the Balance of Payment (as % of service exports) in Azerbaijan in 2009 and the Balance of Payment (as % of service exports) in Chile in 2011?
Offer a terse response. -25.31. What is the difference between the Balance of Payment (as % of service exports) in Azerbaijan in 2009 and the Balance of Payment (as % of service exports) in Malaysia in 2011?
Your response must be concise. 17.53. What is the difference between the Balance of Payment (as % of service exports) of Chile in 2009 and the Balance of Payment (as % of service exports) of Malaysia in 2011?
Offer a terse response. 41.58. What is the difference between the Balance of Payment (as % of service exports) of Sub-Saharan Africa (developing only) in 2009 and the Balance of Payment (as % of service exports) of Azerbaijan in 2012?
Provide a short and direct response. 6.97. What is the difference between the Balance of Payment (as % of service exports) in Sub-Saharan Africa (developing only) in 2009 and the Balance of Payment (as % of service exports) in Chile in 2012?
Provide a short and direct response. -28.63. What is the difference between the Balance of Payment (as % of service exports) of Sub-Saharan Africa (developing only) in 2009 and the Balance of Payment (as % of service exports) of Malaysia in 2012?
Make the answer very short. 10.7. What is the difference between the Balance of Payment (as % of service exports) in Azerbaijan in 2009 and the Balance of Payment (as % of service exports) in Chile in 2012?
Offer a very short reply. -19.48. What is the difference between the Balance of Payment (as % of service exports) in Azerbaijan in 2009 and the Balance of Payment (as % of service exports) in Malaysia in 2012?
Make the answer very short. 19.85. What is the difference between the Balance of Payment (as % of service exports) in Chile in 2009 and the Balance of Payment (as % of service exports) in Malaysia in 2012?
Give a very brief answer. 43.9. What is the difference between the Balance of Payment (as % of service exports) of Sub-Saharan Africa (developing only) in 2010 and the Balance of Payment (as % of service exports) of Azerbaijan in 2011?
Offer a very short reply. 0.41. What is the difference between the Balance of Payment (as % of service exports) in Sub-Saharan Africa (developing only) in 2010 and the Balance of Payment (as % of service exports) in Chile in 2011?
Offer a very short reply. -31.16. What is the difference between the Balance of Payment (as % of service exports) of Sub-Saharan Africa (developing only) in 2010 and the Balance of Payment (as % of service exports) of Malaysia in 2011?
Make the answer very short. 11.68. What is the difference between the Balance of Payment (as % of service exports) in Azerbaijan in 2010 and the Balance of Payment (as % of service exports) in Chile in 2011?
Keep it short and to the point. -31.01. What is the difference between the Balance of Payment (as % of service exports) in Azerbaijan in 2010 and the Balance of Payment (as % of service exports) in Malaysia in 2011?
Your answer should be compact. 11.83. What is the difference between the Balance of Payment (as % of service exports) in Chile in 2010 and the Balance of Payment (as % of service exports) in Malaysia in 2011?
Ensure brevity in your answer.  43.35. What is the difference between the Balance of Payment (as % of service exports) of Sub-Saharan Africa (developing only) in 2010 and the Balance of Payment (as % of service exports) of Azerbaijan in 2012?
Give a very brief answer. 10.27. What is the difference between the Balance of Payment (as % of service exports) of Sub-Saharan Africa (developing only) in 2010 and the Balance of Payment (as % of service exports) of Chile in 2012?
Keep it short and to the point. -25.33. What is the difference between the Balance of Payment (as % of service exports) of Sub-Saharan Africa (developing only) in 2010 and the Balance of Payment (as % of service exports) of Malaysia in 2012?
Keep it short and to the point. 14. What is the difference between the Balance of Payment (as % of service exports) of Azerbaijan in 2010 and the Balance of Payment (as % of service exports) of Chile in 2012?
Make the answer very short. -25.17. What is the difference between the Balance of Payment (as % of service exports) of Azerbaijan in 2010 and the Balance of Payment (as % of service exports) of Malaysia in 2012?
Make the answer very short. 14.16. What is the difference between the Balance of Payment (as % of service exports) in Chile in 2010 and the Balance of Payment (as % of service exports) in Malaysia in 2012?
Offer a terse response. 45.68. What is the difference between the Balance of Payment (as % of service exports) of Sub-Saharan Africa (developing only) in 2011 and the Balance of Payment (as % of service exports) of Azerbaijan in 2012?
Provide a succinct answer. 9.31. What is the difference between the Balance of Payment (as % of service exports) in Sub-Saharan Africa (developing only) in 2011 and the Balance of Payment (as % of service exports) in Chile in 2012?
Provide a short and direct response. -26.29. What is the difference between the Balance of Payment (as % of service exports) in Sub-Saharan Africa (developing only) in 2011 and the Balance of Payment (as % of service exports) in Malaysia in 2012?
Provide a short and direct response. 13.04. What is the difference between the Balance of Payment (as % of service exports) of Azerbaijan in 2011 and the Balance of Payment (as % of service exports) of Chile in 2012?
Provide a short and direct response. -25.74. What is the difference between the Balance of Payment (as % of service exports) of Azerbaijan in 2011 and the Balance of Payment (as % of service exports) of Malaysia in 2012?
Keep it short and to the point. 13.59. What is the difference between the Balance of Payment (as % of service exports) in Chile in 2011 and the Balance of Payment (as % of service exports) in Malaysia in 2012?
Your answer should be very brief. 45.16. What is the average Balance of Payment (as % of service exports) of Sub-Saharan Africa (developing only) per year?
Make the answer very short. 23.88. What is the average Balance of Payment (as % of service exports) in Azerbaijan per year?
Your response must be concise. 33.55. What is the average Balance of Payment (as % of service exports) of Chile per year?
Offer a very short reply. 57. What is the average Balance of Payment (as % of service exports) in Malaysia per year?
Keep it short and to the point. 17.54. In the year 2006, what is the difference between the Balance of Payment (as % of service exports) of Sub-Saharan Africa (developing only) and Balance of Payment (as % of service exports) of Azerbaijan?
Keep it short and to the point. -21.42. In the year 2006, what is the difference between the Balance of Payment (as % of service exports) in Sub-Saharan Africa (developing only) and Balance of Payment (as % of service exports) in Chile?
Your response must be concise. -36.01. In the year 2006, what is the difference between the Balance of Payment (as % of service exports) of Sub-Saharan Africa (developing only) and Balance of Payment (as % of service exports) of Malaysia?
Ensure brevity in your answer.  4.24. In the year 2006, what is the difference between the Balance of Payment (as % of service exports) of Azerbaijan and Balance of Payment (as % of service exports) of Chile?
Offer a very short reply. -14.59. In the year 2006, what is the difference between the Balance of Payment (as % of service exports) of Azerbaijan and Balance of Payment (as % of service exports) of Malaysia?
Your answer should be compact. 25.66. In the year 2006, what is the difference between the Balance of Payment (as % of service exports) in Chile and Balance of Payment (as % of service exports) in Malaysia?
Offer a terse response. 40.24. In the year 2007, what is the difference between the Balance of Payment (as % of service exports) of Sub-Saharan Africa (developing only) and Balance of Payment (as % of service exports) of Azerbaijan?
Your response must be concise. -21.74. In the year 2007, what is the difference between the Balance of Payment (as % of service exports) in Sub-Saharan Africa (developing only) and Balance of Payment (as % of service exports) in Chile?
Give a very brief answer. -36.06. In the year 2007, what is the difference between the Balance of Payment (as % of service exports) of Sub-Saharan Africa (developing only) and Balance of Payment (as % of service exports) of Malaysia?
Ensure brevity in your answer.  -2.47. In the year 2007, what is the difference between the Balance of Payment (as % of service exports) in Azerbaijan and Balance of Payment (as % of service exports) in Chile?
Offer a very short reply. -14.32. In the year 2007, what is the difference between the Balance of Payment (as % of service exports) of Azerbaijan and Balance of Payment (as % of service exports) of Malaysia?
Give a very brief answer. 19.27. In the year 2007, what is the difference between the Balance of Payment (as % of service exports) of Chile and Balance of Payment (as % of service exports) of Malaysia?
Make the answer very short. 33.59. In the year 2008, what is the difference between the Balance of Payment (as % of service exports) in Sub-Saharan Africa (developing only) and Balance of Payment (as % of service exports) in Azerbaijan?
Ensure brevity in your answer.  -24.27. In the year 2008, what is the difference between the Balance of Payment (as % of service exports) of Sub-Saharan Africa (developing only) and Balance of Payment (as % of service exports) of Chile?
Your answer should be very brief. -36.77. In the year 2008, what is the difference between the Balance of Payment (as % of service exports) in Sub-Saharan Africa (developing only) and Balance of Payment (as % of service exports) in Malaysia?
Your response must be concise. 1.32. In the year 2008, what is the difference between the Balance of Payment (as % of service exports) in Azerbaijan and Balance of Payment (as % of service exports) in Chile?
Offer a terse response. -12.5. In the year 2008, what is the difference between the Balance of Payment (as % of service exports) in Azerbaijan and Balance of Payment (as % of service exports) in Malaysia?
Ensure brevity in your answer.  25.58. In the year 2008, what is the difference between the Balance of Payment (as % of service exports) of Chile and Balance of Payment (as % of service exports) of Malaysia?
Offer a very short reply. 38.08. In the year 2009, what is the difference between the Balance of Payment (as % of service exports) of Sub-Saharan Africa (developing only) and Balance of Payment (as % of service exports) of Azerbaijan?
Provide a short and direct response. -9.16. In the year 2009, what is the difference between the Balance of Payment (as % of service exports) in Sub-Saharan Africa (developing only) and Balance of Payment (as % of service exports) in Chile?
Give a very brief answer. -33.21. In the year 2009, what is the difference between the Balance of Payment (as % of service exports) in Sub-Saharan Africa (developing only) and Balance of Payment (as % of service exports) in Malaysia?
Give a very brief answer. 6.8. In the year 2009, what is the difference between the Balance of Payment (as % of service exports) in Azerbaijan and Balance of Payment (as % of service exports) in Chile?
Make the answer very short. -24.05. In the year 2009, what is the difference between the Balance of Payment (as % of service exports) of Azerbaijan and Balance of Payment (as % of service exports) of Malaysia?
Keep it short and to the point. 15.95. In the year 2009, what is the difference between the Balance of Payment (as % of service exports) of Chile and Balance of Payment (as % of service exports) of Malaysia?
Your answer should be very brief. 40. In the year 2010, what is the difference between the Balance of Payment (as % of service exports) of Sub-Saharan Africa (developing only) and Balance of Payment (as % of service exports) of Azerbaijan?
Your response must be concise. -0.16. In the year 2010, what is the difference between the Balance of Payment (as % of service exports) in Sub-Saharan Africa (developing only) and Balance of Payment (as % of service exports) in Chile?
Your response must be concise. -31.67. In the year 2010, what is the difference between the Balance of Payment (as % of service exports) in Sub-Saharan Africa (developing only) and Balance of Payment (as % of service exports) in Malaysia?
Offer a very short reply. 10.44. In the year 2010, what is the difference between the Balance of Payment (as % of service exports) of Azerbaijan and Balance of Payment (as % of service exports) of Chile?
Keep it short and to the point. -31.52. In the year 2010, what is the difference between the Balance of Payment (as % of service exports) in Azerbaijan and Balance of Payment (as % of service exports) in Malaysia?
Make the answer very short. 10.6. In the year 2010, what is the difference between the Balance of Payment (as % of service exports) in Chile and Balance of Payment (as % of service exports) in Malaysia?
Give a very brief answer. 42.12. In the year 2011, what is the difference between the Balance of Payment (as % of service exports) of Sub-Saharan Africa (developing only) and Balance of Payment (as % of service exports) of Azerbaijan?
Your answer should be very brief. -0.55. In the year 2011, what is the difference between the Balance of Payment (as % of service exports) in Sub-Saharan Africa (developing only) and Balance of Payment (as % of service exports) in Chile?
Offer a very short reply. -32.12. In the year 2011, what is the difference between the Balance of Payment (as % of service exports) of Sub-Saharan Africa (developing only) and Balance of Payment (as % of service exports) of Malaysia?
Provide a short and direct response. 10.72. In the year 2011, what is the difference between the Balance of Payment (as % of service exports) of Azerbaijan and Balance of Payment (as % of service exports) of Chile?
Offer a very short reply. -31.58. In the year 2011, what is the difference between the Balance of Payment (as % of service exports) in Azerbaijan and Balance of Payment (as % of service exports) in Malaysia?
Your answer should be compact. 11.26. In the year 2011, what is the difference between the Balance of Payment (as % of service exports) in Chile and Balance of Payment (as % of service exports) in Malaysia?
Your answer should be very brief. 42.84. In the year 2012, what is the difference between the Balance of Payment (as % of service exports) of Sub-Saharan Africa (developing only) and Balance of Payment (as % of service exports) of Azerbaijan?
Keep it short and to the point. 9.61. In the year 2012, what is the difference between the Balance of Payment (as % of service exports) in Sub-Saharan Africa (developing only) and Balance of Payment (as % of service exports) in Chile?
Ensure brevity in your answer.  -25.99. In the year 2012, what is the difference between the Balance of Payment (as % of service exports) in Sub-Saharan Africa (developing only) and Balance of Payment (as % of service exports) in Malaysia?
Your answer should be compact. 13.34. In the year 2012, what is the difference between the Balance of Payment (as % of service exports) of Azerbaijan and Balance of Payment (as % of service exports) of Chile?
Keep it short and to the point. -35.6. In the year 2012, what is the difference between the Balance of Payment (as % of service exports) in Azerbaijan and Balance of Payment (as % of service exports) in Malaysia?
Keep it short and to the point. 3.73. In the year 2012, what is the difference between the Balance of Payment (as % of service exports) of Chile and Balance of Payment (as % of service exports) of Malaysia?
Offer a terse response. 39.33. What is the ratio of the Balance of Payment (as % of service exports) of Sub-Saharan Africa (developing only) in 2006 to that in 2007?
Keep it short and to the point. 1.08. What is the ratio of the Balance of Payment (as % of service exports) in Azerbaijan in 2006 to that in 2007?
Provide a succinct answer. 1.03. What is the ratio of the Balance of Payment (as % of service exports) of Chile in 2006 to that in 2007?
Ensure brevity in your answer.  1.03. What is the ratio of the Balance of Payment (as % of service exports) in Malaysia in 2006 to that in 2007?
Make the answer very short. 0.8. What is the ratio of the Balance of Payment (as % of service exports) in Sub-Saharan Africa (developing only) in 2006 to that in 2008?
Offer a terse response. 1.03. What is the ratio of the Balance of Payment (as % of service exports) of Azerbaijan in 2006 to that in 2008?
Ensure brevity in your answer.  0.95. What is the ratio of the Balance of Payment (as % of service exports) in Malaysia in 2006 to that in 2008?
Your answer should be very brief. 0.9. What is the ratio of the Balance of Payment (as % of service exports) in Sub-Saharan Africa (developing only) in 2006 to that in 2009?
Keep it short and to the point. 1.07. What is the ratio of the Balance of Payment (as % of service exports) of Azerbaijan in 2006 to that in 2009?
Ensure brevity in your answer.  1.44. What is the ratio of the Balance of Payment (as % of service exports) in Chile in 2006 to that in 2009?
Provide a short and direct response. 1.08. What is the ratio of the Balance of Payment (as % of service exports) in Malaysia in 2006 to that in 2009?
Provide a succinct answer. 1.26. What is the ratio of the Balance of Payment (as % of service exports) of Sub-Saharan Africa (developing only) in 2006 to that in 2010?
Your answer should be very brief. 0.93. What is the ratio of the Balance of Payment (as % of service exports) in Azerbaijan in 2006 to that in 2010?
Provide a succinct answer. 1.76. What is the ratio of the Balance of Payment (as % of service exports) in Chile in 2006 to that in 2010?
Offer a very short reply. 1.05. What is the ratio of the Balance of Payment (as % of service exports) of Malaysia in 2006 to that in 2010?
Ensure brevity in your answer.  1.29. What is the ratio of the Balance of Payment (as % of service exports) in Sub-Saharan Africa (developing only) in 2006 to that in 2011?
Offer a very short reply. 0.97. What is the ratio of the Balance of Payment (as % of service exports) in Azerbaijan in 2006 to that in 2011?
Provide a succinct answer. 1.79. What is the ratio of the Balance of Payment (as % of service exports) in Chile in 2006 to that in 2011?
Give a very brief answer. 1.05. What is the ratio of the Balance of Payment (as % of service exports) of Malaysia in 2006 to that in 2011?
Ensure brevity in your answer.  1.41. What is the ratio of the Balance of Payment (as % of service exports) in Sub-Saharan Africa (developing only) in 2006 to that in 2012?
Provide a short and direct response. 0.96. What is the ratio of the Balance of Payment (as % of service exports) in Azerbaijan in 2006 to that in 2012?
Make the answer very short. 2.94. What is the ratio of the Balance of Payment (as % of service exports) of Chile in 2006 to that in 2012?
Your response must be concise. 1.18. What is the ratio of the Balance of Payment (as % of service exports) in Malaysia in 2006 to that in 2012?
Provide a succinct answer. 1.69. What is the ratio of the Balance of Payment (as % of service exports) in Sub-Saharan Africa (developing only) in 2007 to that in 2008?
Provide a short and direct response. 0.95. What is the ratio of the Balance of Payment (as % of service exports) in Azerbaijan in 2007 to that in 2008?
Give a very brief answer. 0.92. What is the ratio of the Balance of Payment (as % of service exports) of Chile in 2007 to that in 2008?
Your answer should be compact. 0.97. What is the ratio of the Balance of Payment (as % of service exports) in Malaysia in 2007 to that in 2008?
Give a very brief answer. 1.12. What is the ratio of the Balance of Payment (as % of service exports) in Sub-Saharan Africa (developing only) in 2007 to that in 2009?
Ensure brevity in your answer.  0.99. What is the ratio of the Balance of Payment (as % of service exports) of Azerbaijan in 2007 to that in 2009?
Offer a very short reply. 1.39. What is the ratio of the Balance of Payment (as % of service exports) in Chile in 2007 to that in 2009?
Provide a succinct answer. 1.05. What is the ratio of the Balance of Payment (as % of service exports) in Malaysia in 2007 to that in 2009?
Ensure brevity in your answer.  1.58. What is the ratio of the Balance of Payment (as % of service exports) of Sub-Saharan Africa (developing only) in 2007 to that in 2010?
Your answer should be compact. 0.86. What is the ratio of the Balance of Payment (as % of service exports) of Azerbaijan in 2007 to that in 2010?
Keep it short and to the point. 1.7. What is the ratio of the Balance of Payment (as % of service exports) in Chile in 2007 to that in 2010?
Make the answer very short. 1.01. What is the ratio of the Balance of Payment (as % of service exports) of Malaysia in 2007 to that in 2010?
Offer a very short reply. 1.61. What is the ratio of the Balance of Payment (as % of service exports) of Sub-Saharan Africa (developing only) in 2007 to that in 2011?
Keep it short and to the point. 0.89. What is the ratio of the Balance of Payment (as % of service exports) in Azerbaijan in 2007 to that in 2011?
Offer a terse response. 1.74. What is the ratio of the Balance of Payment (as % of service exports) of Chile in 2007 to that in 2011?
Provide a short and direct response. 1.02. What is the ratio of the Balance of Payment (as % of service exports) in Malaysia in 2007 to that in 2011?
Offer a very short reply. 1.75. What is the ratio of the Balance of Payment (as % of service exports) in Sub-Saharan Africa (developing only) in 2007 to that in 2012?
Offer a terse response. 0.88. What is the ratio of the Balance of Payment (as % of service exports) of Azerbaijan in 2007 to that in 2012?
Ensure brevity in your answer.  2.85. What is the ratio of the Balance of Payment (as % of service exports) of Chile in 2007 to that in 2012?
Your response must be concise. 1.14. What is the ratio of the Balance of Payment (as % of service exports) in Malaysia in 2007 to that in 2012?
Provide a short and direct response. 2.1. What is the ratio of the Balance of Payment (as % of service exports) of Sub-Saharan Africa (developing only) in 2008 to that in 2009?
Offer a very short reply. 1.04. What is the ratio of the Balance of Payment (as % of service exports) in Azerbaijan in 2008 to that in 2009?
Your answer should be very brief. 1.51. What is the ratio of the Balance of Payment (as % of service exports) in Chile in 2008 to that in 2009?
Keep it short and to the point. 1.08. What is the ratio of the Balance of Payment (as % of service exports) in Malaysia in 2008 to that in 2009?
Provide a short and direct response. 1.41. What is the ratio of the Balance of Payment (as % of service exports) of Sub-Saharan Africa (developing only) in 2008 to that in 2010?
Give a very brief answer. 0.91. What is the ratio of the Balance of Payment (as % of service exports) of Azerbaijan in 2008 to that in 2010?
Keep it short and to the point. 1.84. What is the ratio of the Balance of Payment (as % of service exports) in Chile in 2008 to that in 2010?
Offer a terse response. 1.05. What is the ratio of the Balance of Payment (as % of service exports) in Malaysia in 2008 to that in 2010?
Make the answer very short. 1.44. What is the ratio of the Balance of Payment (as % of service exports) of Sub-Saharan Africa (developing only) in 2008 to that in 2011?
Your response must be concise. 0.94. What is the ratio of the Balance of Payment (as % of service exports) in Azerbaijan in 2008 to that in 2011?
Provide a short and direct response. 1.88. What is the ratio of the Balance of Payment (as % of service exports) of Chile in 2008 to that in 2011?
Keep it short and to the point. 1.06. What is the ratio of the Balance of Payment (as % of service exports) in Malaysia in 2008 to that in 2011?
Provide a short and direct response. 1.57. What is the ratio of the Balance of Payment (as % of service exports) in Sub-Saharan Africa (developing only) in 2008 to that in 2012?
Offer a terse response. 0.93. What is the ratio of the Balance of Payment (as % of service exports) of Azerbaijan in 2008 to that in 2012?
Your answer should be compact. 3.09. What is the ratio of the Balance of Payment (as % of service exports) of Chile in 2008 to that in 2012?
Provide a succinct answer. 1.18. What is the ratio of the Balance of Payment (as % of service exports) in Malaysia in 2008 to that in 2012?
Offer a very short reply. 1.88. What is the ratio of the Balance of Payment (as % of service exports) of Sub-Saharan Africa (developing only) in 2009 to that in 2010?
Your answer should be compact. 0.87. What is the ratio of the Balance of Payment (as % of service exports) in Azerbaijan in 2009 to that in 2010?
Provide a short and direct response. 1.22. What is the ratio of the Balance of Payment (as % of service exports) of Chile in 2009 to that in 2010?
Your answer should be compact. 0.97. What is the ratio of the Balance of Payment (as % of service exports) of Malaysia in 2009 to that in 2010?
Provide a succinct answer. 1.02. What is the ratio of the Balance of Payment (as % of service exports) in Sub-Saharan Africa (developing only) in 2009 to that in 2011?
Your answer should be compact. 0.91. What is the ratio of the Balance of Payment (as % of service exports) in Azerbaijan in 2009 to that in 2011?
Offer a very short reply. 1.25. What is the ratio of the Balance of Payment (as % of service exports) of Chile in 2009 to that in 2011?
Provide a succinct answer. 0.98. What is the ratio of the Balance of Payment (as % of service exports) of Malaysia in 2009 to that in 2011?
Offer a terse response. 1.11. What is the ratio of the Balance of Payment (as % of service exports) in Sub-Saharan Africa (developing only) in 2009 to that in 2012?
Give a very brief answer. 0.89. What is the ratio of the Balance of Payment (as % of service exports) in Azerbaijan in 2009 to that in 2012?
Provide a succinct answer. 2.05. What is the ratio of the Balance of Payment (as % of service exports) in Chile in 2009 to that in 2012?
Keep it short and to the point. 1.09. What is the ratio of the Balance of Payment (as % of service exports) of Malaysia in 2009 to that in 2012?
Give a very brief answer. 1.33. What is the ratio of the Balance of Payment (as % of service exports) of Sub-Saharan Africa (developing only) in 2010 to that in 2011?
Provide a short and direct response. 1.04. What is the ratio of the Balance of Payment (as % of service exports) of Azerbaijan in 2010 to that in 2011?
Your answer should be compact. 1.02. What is the ratio of the Balance of Payment (as % of service exports) in Chile in 2010 to that in 2011?
Offer a very short reply. 1.01. What is the ratio of the Balance of Payment (as % of service exports) in Malaysia in 2010 to that in 2011?
Provide a short and direct response. 1.09. What is the ratio of the Balance of Payment (as % of service exports) in Sub-Saharan Africa (developing only) in 2010 to that in 2012?
Make the answer very short. 1.03. What is the ratio of the Balance of Payment (as % of service exports) in Azerbaijan in 2010 to that in 2012?
Your answer should be very brief. 1.68. What is the ratio of the Balance of Payment (as % of service exports) in Chile in 2010 to that in 2012?
Provide a succinct answer. 1.12. What is the ratio of the Balance of Payment (as % of service exports) in Malaysia in 2010 to that in 2012?
Make the answer very short. 1.3. What is the ratio of the Balance of Payment (as % of service exports) in Azerbaijan in 2011 to that in 2012?
Ensure brevity in your answer.  1.64. What is the ratio of the Balance of Payment (as % of service exports) of Chile in 2011 to that in 2012?
Provide a succinct answer. 1.11. What is the ratio of the Balance of Payment (as % of service exports) of Malaysia in 2011 to that in 2012?
Provide a succinct answer. 1.2. What is the difference between the highest and the second highest Balance of Payment (as % of service exports) in Sub-Saharan Africa (developing only)?
Your response must be concise. 0.66. What is the difference between the highest and the second highest Balance of Payment (as % of service exports) of Azerbaijan?
Your answer should be compact. 2.23. What is the difference between the highest and the second highest Balance of Payment (as % of service exports) in Chile?
Provide a short and direct response. 0.14. What is the difference between the highest and the second highest Balance of Payment (as % of service exports) in Malaysia?
Keep it short and to the point. 2.57. What is the difference between the highest and the lowest Balance of Payment (as % of service exports) in Sub-Saharan Africa (developing only)?
Make the answer very short. 3.58. What is the difference between the highest and the lowest Balance of Payment (as % of service exports) of Azerbaijan?
Give a very brief answer. 32.17. What is the difference between the highest and the lowest Balance of Payment (as % of service exports) of Chile?
Provide a short and direct response. 9.07. What is the difference between the highest and the lowest Balance of Payment (as % of service exports) of Malaysia?
Keep it short and to the point. 12.89. 